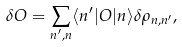<formula> <loc_0><loc_0><loc_500><loc_500>\delta O = \sum _ { n ^ { \prime } , n } \langle n ^ { \prime } | O | n \rangle \delta \rho _ { n , n ^ { \prime } } ,</formula> 